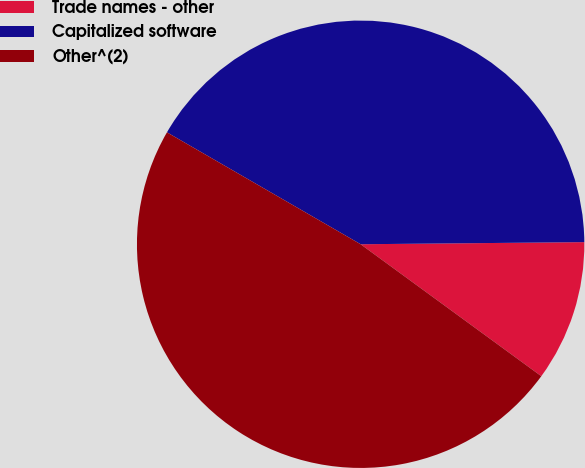Convert chart. <chart><loc_0><loc_0><loc_500><loc_500><pie_chart><fcel>Trade names - other<fcel>Capitalized software<fcel>Other^(2)<nl><fcel>10.19%<fcel>41.51%<fcel>48.3%<nl></chart> 